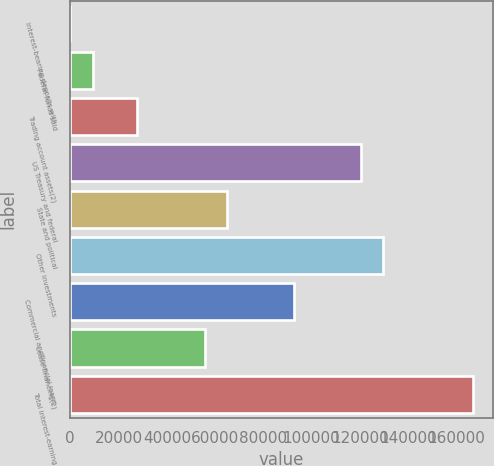Convert chart. <chart><loc_0><loc_0><loc_500><loc_500><bar_chart><fcel>Interest-bearing deposits with<fcel>Federal funds sold<fcel>Trading account assets(2)<fcel>US Treasury and federal<fcel>State and political<fcel>Other investments<fcel>Commercial andfinancial loans<fcel>Lease financing(2)<fcel>Total interest-earning<nl><fcel>40<fcel>9302.5<fcel>27827.5<fcel>120452<fcel>64877.5<fcel>129715<fcel>92665<fcel>55615<fcel>166765<nl></chart> 